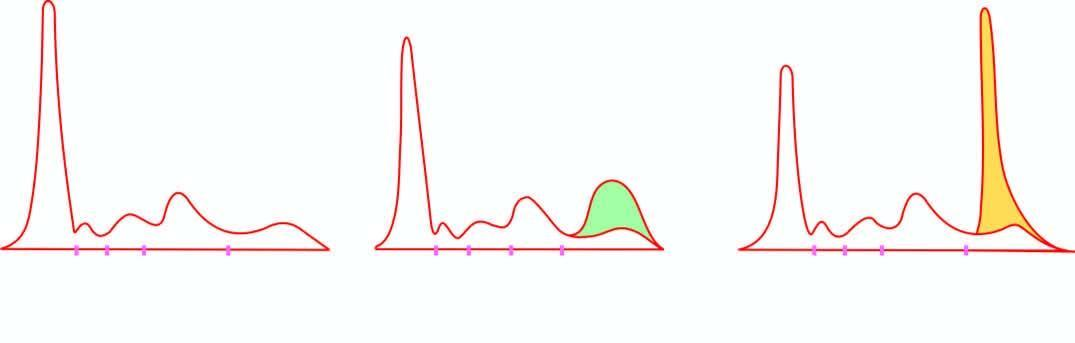did serum electrophoresis show normal serum pattern?
Answer the question using a single word or phrase. Yes 